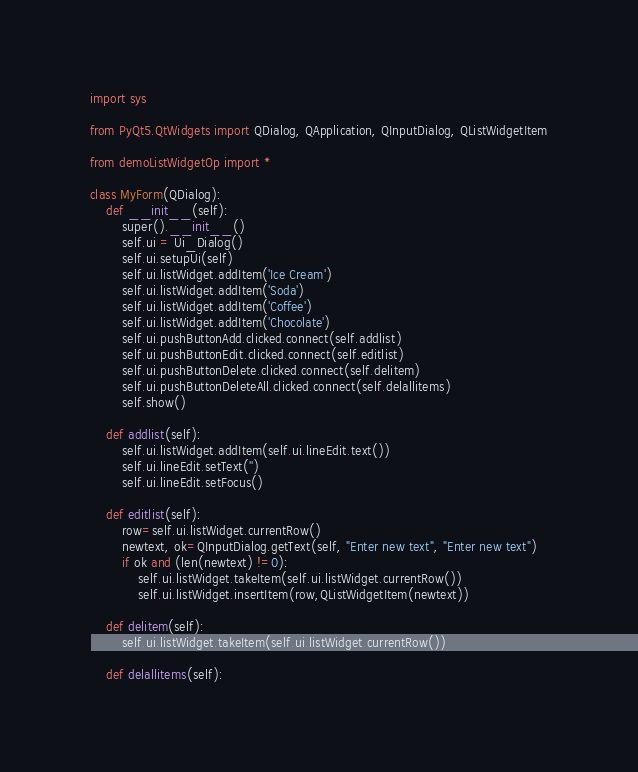<code> <loc_0><loc_0><loc_500><loc_500><_Python_>import sys

from PyQt5.QtWidgets import QDialog, QApplication, QInputDialog, QListWidgetItem

from demoListWidgetOp import *

class MyForm(QDialog):
    def __init__(self):
        super().__init__()
        self.ui = Ui_Dialog()
        self.ui.setupUi(self)
        self.ui.listWidget.addItem('Ice Cream')
        self.ui.listWidget.addItem('Soda')
        self.ui.listWidget.addItem('Coffee')
        self.ui.listWidget.addItem('Chocolate')
        self.ui.pushButtonAdd.clicked.connect(self.addlist)
        self.ui.pushButtonEdit.clicked.connect(self.editlist)
        self.ui.pushButtonDelete.clicked.connect(self.delitem)
        self.ui.pushButtonDeleteAll.clicked.connect(self.delallitems)
        self.show()

    def addlist(self):
        self.ui.listWidget.addItem(self.ui.lineEdit.text())
        self.ui.lineEdit.setText('')
        self.ui.lineEdit.setFocus()
        
    def editlist(self):
        row=self.ui.listWidget.currentRow()
        newtext, ok=QInputDialog.getText(self, "Enter new text", "Enter new text")
        if ok and (len(newtext) !=0):
            self.ui.listWidget.takeItem(self.ui.listWidget.currentRow())
            self.ui.listWidget.insertItem(row,QListWidgetItem(newtext))
        
    def delitem(self):
        self.ui.listWidget.takeItem(self.ui.listWidget.currentRow())
       
    def delallitems(self):</code> 